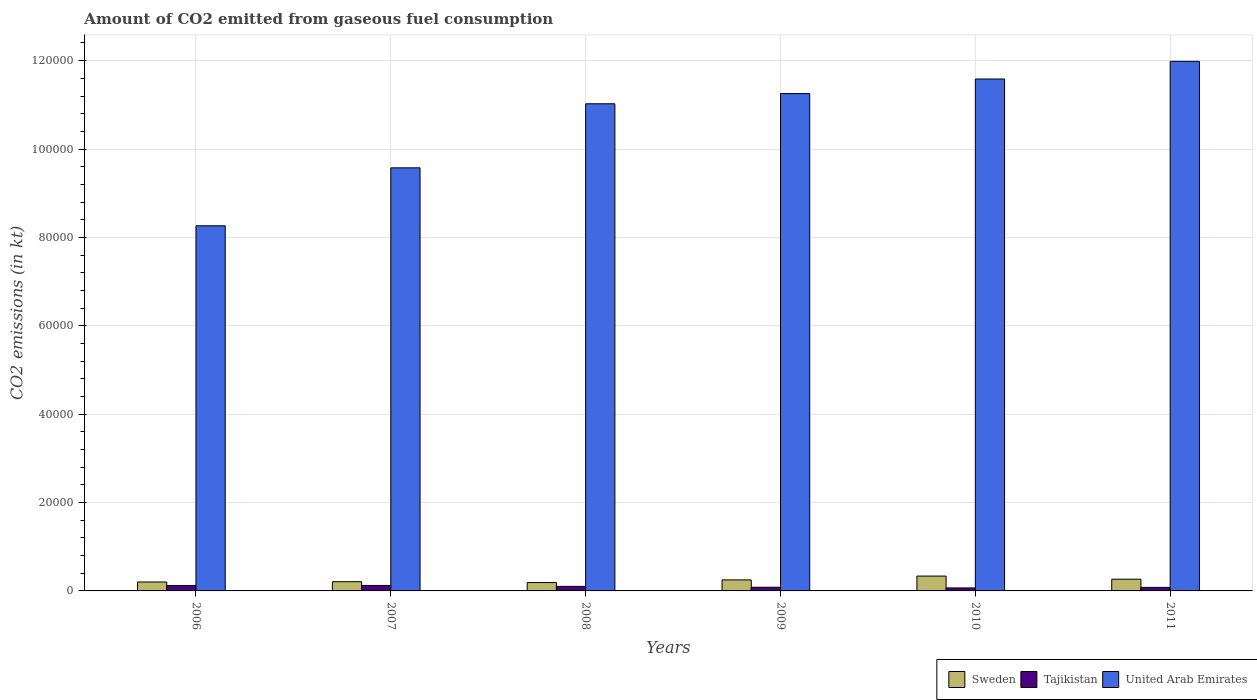How many different coloured bars are there?
Ensure brevity in your answer.  3. How many groups of bars are there?
Your response must be concise. 6. How many bars are there on the 4th tick from the left?
Provide a succinct answer. 3. In how many cases, is the number of bars for a given year not equal to the number of legend labels?
Offer a terse response. 0. What is the amount of CO2 emitted in United Arab Emirates in 2009?
Your answer should be very brief. 1.13e+05. Across all years, what is the maximum amount of CO2 emitted in Sweden?
Ensure brevity in your answer.  3358.97. Across all years, what is the minimum amount of CO2 emitted in United Arab Emirates?
Provide a short and direct response. 8.26e+04. In which year was the amount of CO2 emitted in United Arab Emirates maximum?
Keep it short and to the point. 2011. What is the total amount of CO2 emitted in Sweden in the graph?
Offer a terse response. 1.45e+04. What is the difference between the amount of CO2 emitted in United Arab Emirates in 2007 and that in 2009?
Ensure brevity in your answer.  -1.68e+04. What is the difference between the amount of CO2 emitted in United Arab Emirates in 2008 and the amount of CO2 emitted in Tajikistan in 2006?
Your answer should be very brief. 1.09e+05. What is the average amount of CO2 emitted in United Arab Emirates per year?
Your answer should be very brief. 1.06e+05. In the year 2010, what is the difference between the amount of CO2 emitted in Tajikistan and amount of CO2 emitted in Sweden?
Ensure brevity in your answer.  -2680.58. What is the ratio of the amount of CO2 emitted in Tajikistan in 2006 to that in 2010?
Your answer should be very brief. 1.82. Is the amount of CO2 emitted in United Arab Emirates in 2008 less than that in 2011?
Make the answer very short. Yes. Is the difference between the amount of CO2 emitted in Tajikistan in 2006 and 2011 greater than the difference between the amount of CO2 emitted in Sweden in 2006 and 2011?
Ensure brevity in your answer.  Yes. What is the difference between the highest and the second highest amount of CO2 emitted in Sweden?
Make the answer very short. 704.06. What is the difference between the highest and the lowest amount of CO2 emitted in Sweden?
Your response must be concise. 1466.8. Is the sum of the amount of CO2 emitted in Sweden in 2006 and 2011 greater than the maximum amount of CO2 emitted in United Arab Emirates across all years?
Offer a terse response. No. What does the 3rd bar from the left in 2009 represents?
Keep it short and to the point. United Arab Emirates. What does the 1st bar from the right in 2010 represents?
Your response must be concise. United Arab Emirates. How many years are there in the graph?
Offer a very short reply. 6. What is the difference between two consecutive major ticks on the Y-axis?
Keep it short and to the point. 2.00e+04. Are the values on the major ticks of Y-axis written in scientific E-notation?
Give a very brief answer. No. Does the graph contain grids?
Your response must be concise. Yes. Where does the legend appear in the graph?
Offer a terse response. Bottom right. How many legend labels are there?
Your response must be concise. 3. What is the title of the graph?
Provide a succinct answer. Amount of CO2 emitted from gaseous fuel consumption. Does "Lithuania" appear as one of the legend labels in the graph?
Make the answer very short. No. What is the label or title of the X-axis?
Your response must be concise. Years. What is the label or title of the Y-axis?
Ensure brevity in your answer.  CO2 emissions (in kt). What is the CO2 emissions (in kt) of Sweden in 2006?
Offer a terse response. 2020.52. What is the CO2 emissions (in kt) in Tajikistan in 2006?
Provide a succinct answer. 1232.11. What is the CO2 emissions (in kt) of United Arab Emirates in 2006?
Make the answer very short. 8.26e+04. What is the CO2 emissions (in kt) of Sweden in 2007?
Provide a short and direct response. 2086.52. What is the CO2 emissions (in kt) in Tajikistan in 2007?
Offer a terse response. 1239.45. What is the CO2 emissions (in kt) of United Arab Emirates in 2007?
Make the answer very short. 9.57e+04. What is the CO2 emissions (in kt) of Sweden in 2008?
Offer a very short reply. 1892.17. What is the CO2 emissions (in kt) in Tajikistan in 2008?
Keep it short and to the point. 1026.76. What is the CO2 emissions (in kt) of United Arab Emirates in 2008?
Offer a very short reply. 1.10e+05. What is the CO2 emissions (in kt) in Sweden in 2009?
Offer a terse response. 2493.56. What is the CO2 emissions (in kt) in Tajikistan in 2009?
Your answer should be very brief. 832.41. What is the CO2 emissions (in kt) in United Arab Emirates in 2009?
Give a very brief answer. 1.13e+05. What is the CO2 emissions (in kt) in Sweden in 2010?
Provide a short and direct response. 3358.97. What is the CO2 emissions (in kt) in Tajikistan in 2010?
Your response must be concise. 678.39. What is the CO2 emissions (in kt) in United Arab Emirates in 2010?
Your response must be concise. 1.16e+05. What is the CO2 emissions (in kt) of Sweden in 2011?
Make the answer very short. 2654.91. What is the CO2 emissions (in kt) in Tajikistan in 2011?
Your response must be concise. 799.41. What is the CO2 emissions (in kt) in United Arab Emirates in 2011?
Give a very brief answer. 1.20e+05. Across all years, what is the maximum CO2 emissions (in kt) in Sweden?
Provide a succinct answer. 3358.97. Across all years, what is the maximum CO2 emissions (in kt) in Tajikistan?
Your answer should be compact. 1239.45. Across all years, what is the maximum CO2 emissions (in kt) of United Arab Emirates?
Keep it short and to the point. 1.20e+05. Across all years, what is the minimum CO2 emissions (in kt) in Sweden?
Provide a short and direct response. 1892.17. Across all years, what is the minimum CO2 emissions (in kt) of Tajikistan?
Your answer should be compact. 678.39. Across all years, what is the minimum CO2 emissions (in kt) of United Arab Emirates?
Offer a terse response. 8.26e+04. What is the total CO2 emissions (in kt) in Sweden in the graph?
Provide a succinct answer. 1.45e+04. What is the total CO2 emissions (in kt) in Tajikistan in the graph?
Your response must be concise. 5808.53. What is the total CO2 emissions (in kt) in United Arab Emirates in the graph?
Make the answer very short. 6.37e+05. What is the difference between the CO2 emissions (in kt) in Sweden in 2006 and that in 2007?
Offer a terse response. -66.01. What is the difference between the CO2 emissions (in kt) of Tajikistan in 2006 and that in 2007?
Your response must be concise. -7.33. What is the difference between the CO2 emissions (in kt) of United Arab Emirates in 2006 and that in 2007?
Offer a terse response. -1.31e+04. What is the difference between the CO2 emissions (in kt) in Sweden in 2006 and that in 2008?
Make the answer very short. 128.34. What is the difference between the CO2 emissions (in kt) of Tajikistan in 2006 and that in 2008?
Provide a short and direct response. 205.35. What is the difference between the CO2 emissions (in kt) of United Arab Emirates in 2006 and that in 2008?
Your answer should be compact. -2.76e+04. What is the difference between the CO2 emissions (in kt) of Sweden in 2006 and that in 2009?
Your answer should be compact. -473.04. What is the difference between the CO2 emissions (in kt) of Tajikistan in 2006 and that in 2009?
Keep it short and to the point. 399.7. What is the difference between the CO2 emissions (in kt) of United Arab Emirates in 2006 and that in 2009?
Your answer should be very brief. -2.99e+04. What is the difference between the CO2 emissions (in kt) in Sweden in 2006 and that in 2010?
Give a very brief answer. -1338.45. What is the difference between the CO2 emissions (in kt) in Tajikistan in 2006 and that in 2010?
Your answer should be very brief. 553.72. What is the difference between the CO2 emissions (in kt) in United Arab Emirates in 2006 and that in 2010?
Ensure brevity in your answer.  -3.32e+04. What is the difference between the CO2 emissions (in kt) of Sweden in 2006 and that in 2011?
Keep it short and to the point. -634.39. What is the difference between the CO2 emissions (in kt) of Tajikistan in 2006 and that in 2011?
Ensure brevity in your answer.  432.71. What is the difference between the CO2 emissions (in kt) in United Arab Emirates in 2006 and that in 2011?
Your answer should be very brief. -3.72e+04. What is the difference between the CO2 emissions (in kt) in Sweden in 2007 and that in 2008?
Your response must be concise. 194.35. What is the difference between the CO2 emissions (in kt) of Tajikistan in 2007 and that in 2008?
Ensure brevity in your answer.  212.69. What is the difference between the CO2 emissions (in kt) in United Arab Emirates in 2007 and that in 2008?
Give a very brief answer. -1.45e+04. What is the difference between the CO2 emissions (in kt) in Sweden in 2007 and that in 2009?
Ensure brevity in your answer.  -407.04. What is the difference between the CO2 emissions (in kt) of Tajikistan in 2007 and that in 2009?
Provide a short and direct response. 407.04. What is the difference between the CO2 emissions (in kt) of United Arab Emirates in 2007 and that in 2009?
Your answer should be very brief. -1.68e+04. What is the difference between the CO2 emissions (in kt) in Sweden in 2007 and that in 2010?
Provide a succinct answer. -1272.45. What is the difference between the CO2 emissions (in kt) of Tajikistan in 2007 and that in 2010?
Offer a very short reply. 561.05. What is the difference between the CO2 emissions (in kt) of United Arab Emirates in 2007 and that in 2010?
Provide a short and direct response. -2.01e+04. What is the difference between the CO2 emissions (in kt) of Sweden in 2007 and that in 2011?
Keep it short and to the point. -568.38. What is the difference between the CO2 emissions (in kt) of Tajikistan in 2007 and that in 2011?
Provide a short and direct response. 440.04. What is the difference between the CO2 emissions (in kt) of United Arab Emirates in 2007 and that in 2011?
Give a very brief answer. -2.41e+04. What is the difference between the CO2 emissions (in kt) in Sweden in 2008 and that in 2009?
Make the answer very short. -601.39. What is the difference between the CO2 emissions (in kt) in Tajikistan in 2008 and that in 2009?
Ensure brevity in your answer.  194.35. What is the difference between the CO2 emissions (in kt) in United Arab Emirates in 2008 and that in 2009?
Offer a terse response. -2310.21. What is the difference between the CO2 emissions (in kt) of Sweden in 2008 and that in 2010?
Provide a short and direct response. -1466.8. What is the difference between the CO2 emissions (in kt) in Tajikistan in 2008 and that in 2010?
Keep it short and to the point. 348.37. What is the difference between the CO2 emissions (in kt) of United Arab Emirates in 2008 and that in 2010?
Ensure brevity in your answer.  -5606.84. What is the difference between the CO2 emissions (in kt) in Sweden in 2008 and that in 2011?
Your response must be concise. -762.74. What is the difference between the CO2 emissions (in kt) of Tajikistan in 2008 and that in 2011?
Give a very brief answer. 227.35. What is the difference between the CO2 emissions (in kt) in United Arab Emirates in 2008 and that in 2011?
Offer a terse response. -9600.21. What is the difference between the CO2 emissions (in kt) of Sweden in 2009 and that in 2010?
Ensure brevity in your answer.  -865.41. What is the difference between the CO2 emissions (in kt) in Tajikistan in 2009 and that in 2010?
Your response must be concise. 154.01. What is the difference between the CO2 emissions (in kt) in United Arab Emirates in 2009 and that in 2010?
Ensure brevity in your answer.  -3296.63. What is the difference between the CO2 emissions (in kt) of Sweden in 2009 and that in 2011?
Keep it short and to the point. -161.35. What is the difference between the CO2 emissions (in kt) in Tajikistan in 2009 and that in 2011?
Provide a short and direct response. 33. What is the difference between the CO2 emissions (in kt) in United Arab Emirates in 2009 and that in 2011?
Your answer should be very brief. -7290. What is the difference between the CO2 emissions (in kt) of Sweden in 2010 and that in 2011?
Your answer should be compact. 704.06. What is the difference between the CO2 emissions (in kt) in Tajikistan in 2010 and that in 2011?
Provide a short and direct response. -121.01. What is the difference between the CO2 emissions (in kt) of United Arab Emirates in 2010 and that in 2011?
Offer a very short reply. -3993.36. What is the difference between the CO2 emissions (in kt) in Sweden in 2006 and the CO2 emissions (in kt) in Tajikistan in 2007?
Your response must be concise. 781.07. What is the difference between the CO2 emissions (in kt) of Sweden in 2006 and the CO2 emissions (in kt) of United Arab Emirates in 2007?
Keep it short and to the point. -9.37e+04. What is the difference between the CO2 emissions (in kt) in Tajikistan in 2006 and the CO2 emissions (in kt) in United Arab Emirates in 2007?
Give a very brief answer. -9.45e+04. What is the difference between the CO2 emissions (in kt) in Sweden in 2006 and the CO2 emissions (in kt) in Tajikistan in 2008?
Provide a succinct answer. 993.76. What is the difference between the CO2 emissions (in kt) of Sweden in 2006 and the CO2 emissions (in kt) of United Arab Emirates in 2008?
Provide a short and direct response. -1.08e+05. What is the difference between the CO2 emissions (in kt) in Tajikistan in 2006 and the CO2 emissions (in kt) in United Arab Emirates in 2008?
Give a very brief answer. -1.09e+05. What is the difference between the CO2 emissions (in kt) in Sweden in 2006 and the CO2 emissions (in kt) in Tajikistan in 2009?
Give a very brief answer. 1188.11. What is the difference between the CO2 emissions (in kt) in Sweden in 2006 and the CO2 emissions (in kt) in United Arab Emirates in 2009?
Give a very brief answer. -1.11e+05. What is the difference between the CO2 emissions (in kt) of Tajikistan in 2006 and the CO2 emissions (in kt) of United Arab Emirates in 2009?
Ensure brevity in your answer.  -1.11e+05. What is the difference between the CO2 emissions (in kt) of Sweden in 2006 and the CO2 emissions (in kt) of Tajikistan in 2010?
Give a very brief answer. 1342.12. What is the difference between the CO2 emissions (in kt) in Sweden in 2006 and the CO2 emissions (in kt) in United Arab Emirates in 2010?
Offer a very short reply. -1.14e+05. What is the difference between the CO2 emissions (in kt) of Tajikistan in 2006 and the CO2 emissions (in kt) of United Arab Emirates in 2010?
Your answer should be compact. -1.15e+05. What is the difference between the CO2 emissions (in kt) of Sweden in 2006 and the CO2 emissions (in kt) of Tajikistan in 2011?
Ensure brevity in your answer.  1221.11. What is the difference between the CO2 emissions (in kt) in Sweden in 2006 and the CO2 emissions (in kt) in United Arab Emirates in 2011?
Make the answer very short. -1.18e+05. What is the difference between the CO2 emissions (in kt) in Tajikistan in 2006 and the CO2 emissions (in kt) in United Arab Emirates in 2011?
Your response must be concise. -1.19e+05. What is the difference between the CO2 emissions (in kt) in Sweden in 2007 and the CO2 emissions (in kt) in Tajikistan in 2008?
Offer a terse response. 1059.76. What is the difference between the CO2 emissions (in kt) in Sweden in 2007 and the CO2 emissions (in kt) in United Arab Emirates in 2008?
Your answer should be very brief. -1.08e+05. What is the difference between the CO2 emissions (in kt) of Tajikistan in 2007 and the CO2 emissions (in kt) of United Arab Emirates in 2008?
Your response must be concise. -1.09e+05. What is the difference between the CO2 emissions (in kt) of Sweden in 2007 and the CO2 emissions (in kt) of Tajikistan in 2009?
Your answer should be very brief. 1254.11. What is the difference between the CO2 emissions (in kt) of Sweden in 2007 and the CO2 emissions (in kt) of United Arab Emirates in 2009?
Ensure brevity in your answer.  -1.10e+05. What is the difference between the CO2 emissions (in kt) of Tajikistan in 2007 and the CO2 emissions (in kt) of United Arab Emirates in 2009?
Give a very brief answer. -1.11e+05. What is the difference between the CO2 emissions (in kt) of Sweden in 2007 and the CO2 emissions (in kt) of Tajikistan in 2010?
Provide a short and direct response. 1408.13. What is the difference between the CO2 emissions (in kt) of Sweden in 2007 and the CO2 emissions (in kt) of United Arab Emirates in 2010?
Give a very brief answer. -1.14e+05. What is the difference between the CO2 emissions (in kt) in Tajikistan in 2007 and the CO2 emissions (in kt) in United Arab Emirates in 2010?
Provide a short and direct response. -1.15e+05. What is the difference between the CO2 emissions (in kt) in Sweden in 2007 and the CO2 emissions (in kt) in Tajikistan in 2011?
Your answer should be compact. 1287.12. What is the difference between the CO2 emissions (in kt) in Sweden in 2007 and the CO2 emissions (in kt) in United Arab Emirates in 2011?
Your response must be concise. -1.18e+05. What is the difference between the CO2 emissions (in kt) in Tajikistan in 2007 and the CO2 emissions (in kt) in United Arab Emirates in 2011?
Your answer should be very brief. -1.19e+05. What is the difference between the CO2 emissions (in kt) in Sweden in 2008 and the CO2 emissions (in kt) in Tajikistan in 2009?
Your response must be concise. 1059.76. What is the difference between the CO2 emissions (in kt) of Sweden in 2008 and the CO2 emissions (in kt) of United Arab Emirates in 2009?
Offer a terse response. -1.11e+05. What is the difference between the CO2 emissions (in kt) in Tajikistan in 2008 and the CO2 emissions (in kt) in United Arab Emirates in 2009?
Your answer should be very brief. -1.12e+05. What is the difference between the CO2 emissions (in kt) in Sweden in 2008 and the CO2 emissions (in kt) in Tajikistan in 2010?
Make the answer very short. 1213.78. What is the difference between the CO2 emissions (in kt) in Sweden in 2008 and the CO2 emissions (in kt) in United Arab Emirates in 2010?
Provide a short and direct response. -1.14e+05. What is the difference between the CO2 emissions (in kt) of Tajikistan in 2008 and the CO2 emissions (in kt) of United Arab Emirates in 2010?
Give a very brief answer. -1.15e+05. What is the difference between the CO2 emissions (in kt) in Sweden in 2008 and the CO2 emissions (in kt) in Tajikistan in 2011?
Your answer should be very brief. 1092.77. What is the difference between the CO2 emissions (in kt) of Sweden in 2008 and the CO2 emissions (in kt) of United Arab Emirates in 2011?
Your answer should be very brief. -1.18e+05. What is the difference between the CO2 emissions (in kt) of Tajikistan in 2008 and the CO2 emissions (in kt) of United Arab Emirates in 2011?
Make the answer very short. -1.19e+05. What is the difference between the CO2 emissions (in kt) in Sweden in 2009 and the CO2 emissions (in kt) in Tajikistan in 2010?
Provide a short and direct response. 1815.16. What is the difference between the CO2 emissions (in kt) of Sweden in 2009 and the CO2 emissions (in kt) of United Arab Emirates in 2010?
Make the answer very short. -1.13e+05. What is the difference between the CO2 emissions (in kt) of Tajikistan in 2009 and the CO2 emissions (in kt) of United Arab Emirates in 2010?
Give a very brief answer. -1.15e+05. What is the difference between the CO2 emissions (in kt) of Sweden in 2009 and the CO2 emissions (in kt) of Tajikistan in 2011?
Make the answer very short. 1694.15. What is the difference between the CO2 emissions (in kt) of Sweden in 2009 and the CO2 emissions (in kt) of United Arab Emirates in 2011?
Offer a terse response. -1.17e+05. What is the difference between the CO2 emissions (in kt) in Tajikistan in 2009 and the CO2 emissions (in kt) in United Arab Emirates in 2011?
Your response must be concise. -1.19e+05. What is the difference between the CO2 emissions (in kt) in Sweden in 2010 and the CO2 emissions (in kt) in Tajikistan in 2011?
Your answer should be very brief. 2559.57. What is the difference between the CO2 emissions (in kt) in Sweden in 2010 and the CO2 emissions (in kt) in United Arab Emirates in 2011?
Make the answer very short. -1.16e+05. What is the difference between the CO2 emissions (in kt) of Tajikistan in 2010 and the CO2 emissions (in kt) of United Arab Emirates in 2011?
Give a very brief answer. -1.19e+05. What is the average CO2 emissions (in kt) of Sweden per year?
Ensure brevity in your answer.  2417.78. What is the average CO2 emissions (in kt) in Tajikistan per year?
Give a very brief answer. 968.09. What is the average CO2 emissions (in kt) in United Arab Emirates per year?
Your answer should be very brief. 1.06e+05. In the year 2006, what is the difference between the CO2 emissions (in kt) in Sweden and CO2 emissions (in kt) in Tajikistan?
Keep it short and to the point. 788.4. In the year 2006, what is the difference between the CO2 emissions (in kt) in Sweden and CO2 emissions (in kt) in United Arab Emirates?
Provide a short and direct response. -8.06e+04. In the year 2006, what is the difference between the CO2 emissions (in kt) of Tajikistan and CO2 emissions (in kt) of United Arab Emirates?
Your response must be concise. -8.14e+04. In the year 2007, what is the difference between the CO2 emissions (in kt) of Sweden and CO2 emissions (in kt) of Tajikistan?
Offer a terse response. 847.08. In the year 2007, what is the difference between the CO2 emissions (in kt) of Sweden and CO2 emissions (in kt) of United Arab Emirates?
Offer a terse response. -9.37e+04. In the year 2007, what is the difference between the CO2 emissions (in kt) of Tajikistan and CO2 emissions (in kt) of United Arab Emirates?
Offer a terse response. -9.45e+04. In the year 2008, what is the difference between the CO2 emissions (in kt) of Sweden and CO2 emissions (in kt) of Tajikistan?
Make the answer very short. 865.41. In the year 2008, what is the difference between the CO2 emissions (in kt) of Sweden and CO2 emissions (in kt) of United Arab Emirates?
Provide a succinct answer. -1.08e+05. In the year 2008, what is the difference between the CO2 emissions (in kt) in Tajikistan and CO2 emissions (in kt) in United Arab Emirates?
Provide a succinct answer. -1.09e+05. In the year 2009, what is the difference between the CO2 emissions (in kt) in Sweden and CO2 emissions (in kt) in Tajikistan?
Keep it short and to the point. 1661.15. In the year 2009, what is the difference between the CO2 emissions (in kt) in Sweden and CO2 emissions (in kt) in United Arab Emirates?
Ensure brevity in your answer.  -1.10e+05. In the year 2009, what is the difference between the CO2 emissions (in kt) of Tajikistan and CO2 emissions (in kt) of United Arab Emirates?
Your answer should be compact. -1.12e+05. In the year 2010, what is the difference between the CO2 emissions (in kt) of Sweden and CO2 emissions (in kt) of Tajikistan?
Provide a succinct answer. 2680.58. In the year 2010, what is the difference between the CO2 emissions (in kt) of Sweden and CO2 emissions (in kt) of United Arab Emirates?
Offer a very short reply. -1.12e+05. In the year 2010, what is the difference between the CO2 emissions (in kt) in Tajikistan and CO2 emissions (in kt) in United Arab Emirates?
Offer a terse response. -1.15e+05. In the year 2011, what is the difference between the CO2 emissions (in kt) of Sweden and CO2 emissions (in kt) of Tajikistan?
Provide a short and direct response. 1855.5. In the year 2011, what is the difference between the CO2 emissions (in kt) in Sweden and CO2 emissions (in kt) in United Arab Emirates?
Keep it short and to the point. -1.17e+05. In the year 2011, what is the difference between the CO2 emissions (in kt) in Tajikistan and CO2 emissions (in kt) in United Arab Emirates?
Provide a succinct answer. -1.19e+05. What is the ratio of the CO2 emissions (in kt) of Sweden in 2006 to that in 2007?
Your response must be concise. 0.97. What is the ratio of the CO2 emissions (in kt) in United Arab Emirates in 2006 to that in 2007?
Make the answer very short. 0.86. What is the ratio of the CO2 emissions (in kt) of Sweden in 2006 to that in 2008?
Provide a succinct answer. 1.07. What is the ratio of the CO2 emissions (in kt) of United Arab Emirates in 2006 to that in 2008?
Your answer should be very brief. 0.75. What is the ratio of the CO2 emissions (in kt) in Sweden in 2006 to that in 2009?
Your answer should be compact. 0.81. What is the ratio of the CO2 emissions (in kt) in Tajikistan in 2006 to that in 2009?
Your response must be concise. 1.48. What is the ratio of the CO2 emissions (in kt) of United Arab Emirates in 2006 to that in 2009?
Keep it short and to the point. 0.73. What is the ratio of the CO2 emissions (in kt) in Sweden in 2006 to that in 2010?
Offer a terse response. 0.6. What is the ratio of the CO2 emissions (in kt) in Tajikistan in 2006 to that in 2010?
Ensure brevity in your answer.  1.82. What is the ratio of the CO2 emissions (in kt) of United Arab Emirates in 2006 to that in 2010?
Your answer should be compact. 0.71. What is the ratio of the CO2 emissions (in kt) of Sweden in 2006 to that in 2011?
Offer a terse response. 0.76. What is the ratio of the CO2 emissions (in kt) of Tajikistan in 2006 to that in 2011?
Your answer should be very brief. 1.54. What is the ratio of the CO2 emissions (in kt) in United Arab Emirates in 2006 to that in 2011?
Keep it short and to the point. 0.69. What is the ratio of the CO2 emissions (in kt) in Sweden in 2007 to that in 2008?
Offer a very short reply. 1.1. What is the ratio of the CO2 emissions (in kt) of Tajikistan in 2007 to that in 2008?
Make the answer very short. 1.21. What is the ratio of the CO2 emissions (in kt) in United Arab Emirates in 2007 to that in 2008?
Your answer should be very brief. 0.87. What is the ratio of the CO2 emissions (in kt) of Sweden in 2007 to that in 2009?
Offer a terse response. 0.84. What is the ratio of the CO2 emissions (in kt) of Tajikistan in 2007 to that in 2009?
Your response must be concise. 1.49. What is the ratio of the CO2 emissions (in kt) of United Arab Emirates in 2007 to that in 2009?
Provide a short and direct response. 0.85. What is the ratio of the CO2 emissions (in kt) of Sweden in 2007 to that in 2010?
Provide a succinct answer. 0.62. What is the ratio of the CO2 emissions (in kt) in Tajikistan in 2007 to that in 2010?
Your answer should be compact. 1.83. What is the ratio of the CO2 emissions (in kt) of United Arab Emirates in 2007 to that in 2010?
Provide a succinct answer. 0.83. What is the ratio of the CO2 emissions (in kt) of Sweden in 2007 to that in 2011?
Your answer should be compact. 0.79. What is the ratio of the CO2 emissions (in kt) of Tajikistan in 2007 to that in 2011?
Your response must be concise. 1.55. What is the ratio of the CO2 emissions (in kt) in United Arab Emirates in 2007 to that in 2011?
Your answer should be very brief. 0.8. What is the ratio of the CO2 emissions (in kt) of Sweden in 2008 to that in 2009?
Keep it short and to the point. 0.76. What is the ratio of the CO2 emissions (in kt) of Tajikistan in 2008 to that in 2009?
Provide a succinct answer. 1.23. What is the ratio of the CO2 emissions (in kt) in United Arab Emirates in 2008 to that in 2009?
Your answer should be compact. 0.98. What is the ratio of the CO2 emissions (in kt) in Sweden in 2008 to that in 2010?
Keep it short and to the point. 0.56. What is the ratio of the CO2 emissions (in kt) in Tajikistan in 2008 to that in 2010?
Make the answer very short. 1.51. What is the ratio of the CO2 emissions (in kt) of United Arab Emirates in 2008 to that in 2010?
Keep it short and to the point. 0.95. What is the ratio of the CO2 emissions (in kt) of Sweden in 2008 to that in 2011?
Keep it short and to the point. 0.71. What is the ratio of the CO2 emissions (in kt) of Tajikistan in 2008 to that in 2011?
Your answer should be compact. 1.28. What is the ratio of the CO2 emissions (in kt) of United Arab Emirates in 2008 to that in 2011?
Your answer should be compact. 0.92. What is the ratio of the CO2 emissions (in kt) of Sweden in 2009 to that in 2010?
Offer a terse response. 0.74. What is the ratio of the CO2 emissions (in kt) in Tajikistan in 2009 to that in 2010?
Provide a short and direct response. 1.23. What is the ratio of the CO2 emissions (in kt) in United Arab Emirates in 2009 to that in 2010?
Make the answer very short. 0.97. What is the ratio of the CO2 emissions (in kt) in Sweden in 2009 to that in 2011?
Ensure brevity in your answer.  0.94. What is the ratio of the CO2 emissions (in kt) in Tajikistan in 2009 to that in 2011?
Give a very brief answer. 1.04. What is the ratio of the CO2 emissions (in kt) in United Arab Emirates in 2009 to that in 2011?
Provide a short and direct response. 0.94. What is the ratio of the CO2 emissions (in kt) of Sweden in 2010 to that in 2011?
Provide a short and direct response. 1.27. What is the ratio of the CO2 emissions (in kt) of Tajikistan in 2010 to that in 2011?
Your answer should be compact. 0.85. What is the ratio of the CO2 emissions (in kt) in United Arab Emirates in 2010 to that in 2011?
Your answer should be compact. 0.97. What is the difference between the highest and the second highest CO2 emissions (in kt) in Sweden?
Your response must be concise. 704.06. What is the difference between the highest and the second highest CO2 emissions (in kt) of Tajikistan?
Provide a succinct answer. 7.33. What is the difference between the highest and the second highest CO2 emissions (in kt) in United Arab Emirates?
Make the answer very short. 3993.36. What is the difference between the highest and the lowest CO2 emissions (in kt) of Sweden?
Provide a short and direct response. 1466.8. What is the difference between the highest and the lowest CO2 emissions (in kt) of Tajikistan?
Provide a succinct answer. 561.05. What is the difference between the highest and the lowest CO2 emissions (in kt) in United Arab Emirates?
Offer a terse response. 3.72e+04. 